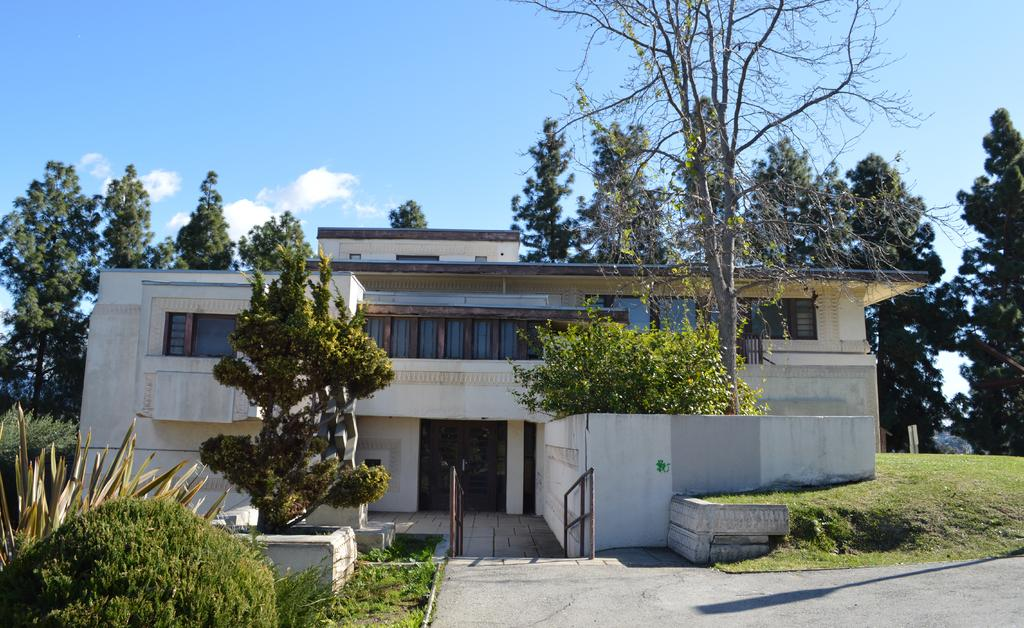What type of structure is visible in the image? There is a house in the image. What type of vegetation can be seen in the image? There are trees, grass, and plants in the image. What type of pathway is present in the image? There is a road in the image. What part of the natural environment is visible in the image? The sky is visible in the image. What effect does the theory have on the surprise in the image? There is no effect, theory, or surprise present in the image. 